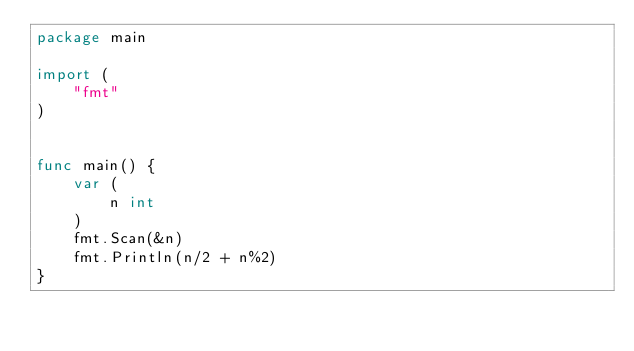Convert code to text. <code><loc_0><loc_0><loc_500><loc_500><_Go_>package main

import (
	"fmt"
)


func main() {
	var (
		n int
	)
	fmt.Scan(&n)
	fmt.Println(n/2 + n%2)
}
</code> 